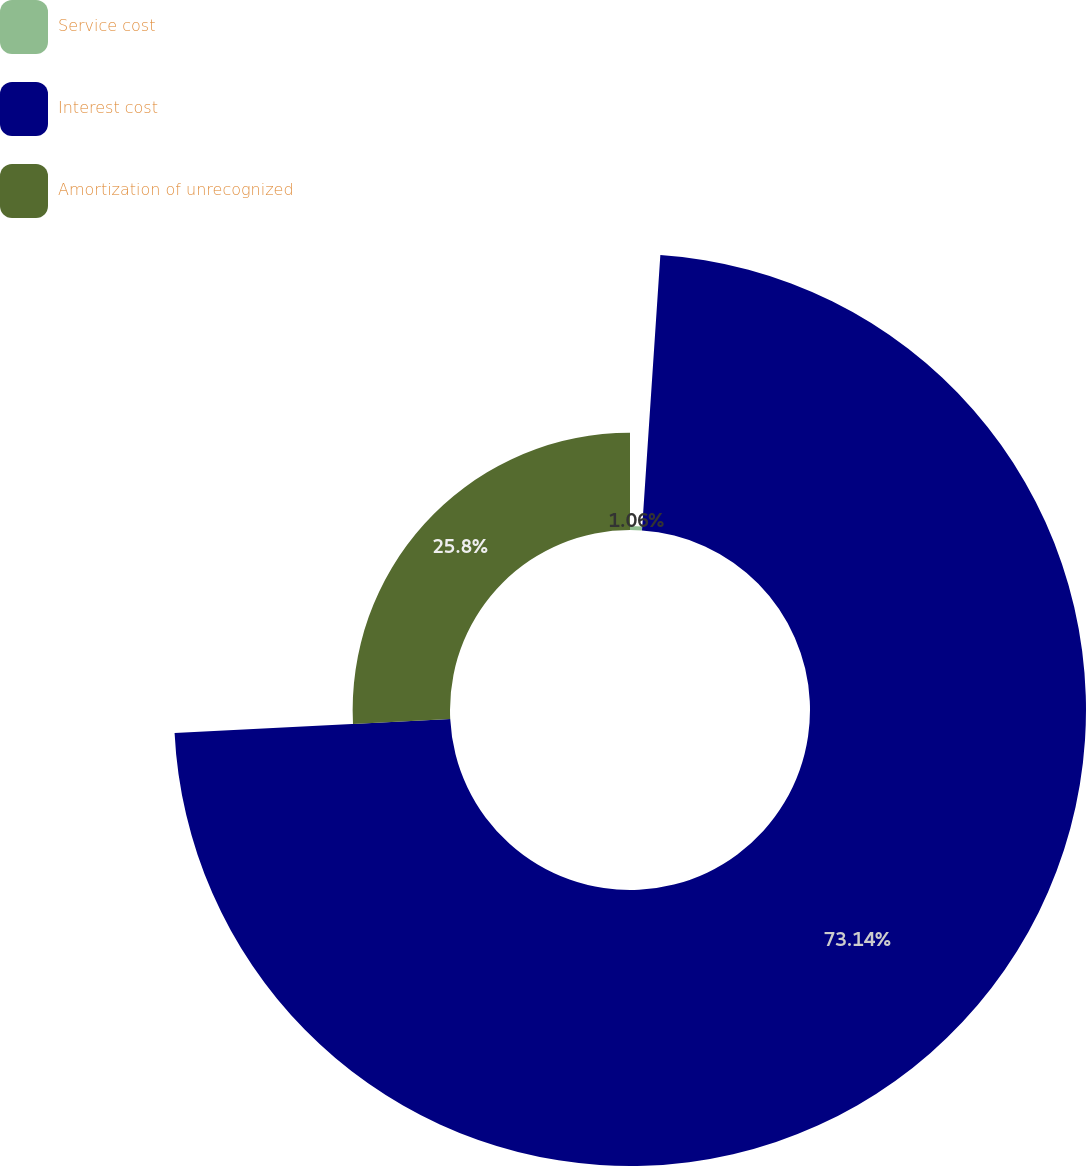Convert chart. <chart><loc_0><loc_0><loc_500><loc_500><pie_chart><fcel>Service cost<fcel>Interest cost<fcel>Amortization of unrecognized<nl><fcel>1.06%<fcel>73.14%<fcel>25.8%<nl></chart> 